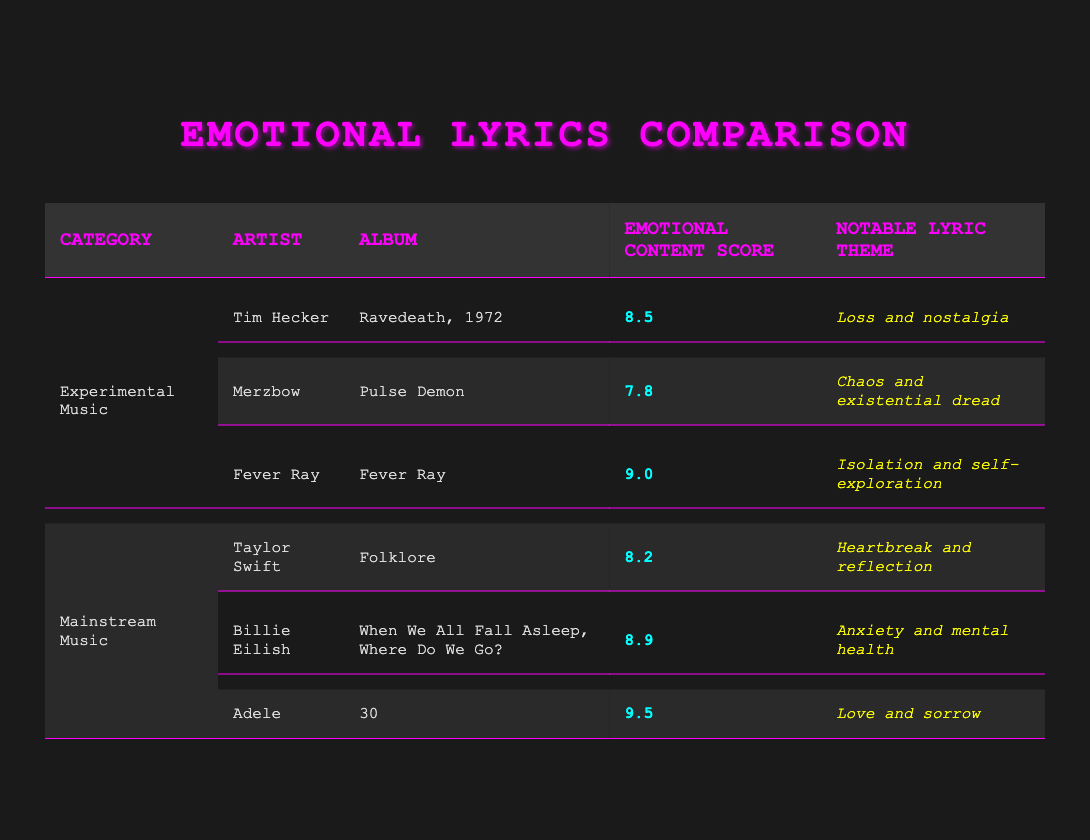What is the emotional content score of Fever Ray's album? The table shows that Fever Ray's album "Fever Ray" has an emotional content score of 9.0.
Answer: 9.0 Which artist has the highest emotional content score in mainstream music? From the table, Adele has the highest emotional content score of 9.5 in mainstream music, compared to Taylor Swift's 8.2 and Billie Eilish's 8.9.
Answer: Adele What is the notable lyric theme of Tim Hecker's album? According to the table, Tim Hecker's album "Ravedeath, 1972" has the notable lyric theme of "Loss and nostalgia."
Answer: Loss and nostalgia What is the average emotional content score of experimental music? The emotional content scores for experimental music are 8.5, 7.8, and 9.0. Summing these values gives 25.3 (8.5 + 7.8 + 9.0) and dividing by 3 (number of artists) results in an average of 8.43.
Answer: 8.43 Is there any artist in experimental music with an emotional content score higher than 9.0? The table lists Fever Ray with a score of 9.0, but no other experimental artist's score exceeds this; Tim Hecker and Merzbow score lower. Therefore, the answer is no.
Answer: No Which mainstream artist has a notable lyric theme related to anxiety? The table indicates that Billie Eilish has a notable lyric theme of "Anxiety and mental health."
Answer: Billie Eilish What is the sum of the emotional content scores for both Tim Hecker and Taylor Swift? Tim Hecker's score is 8.5 and Taylor Swift's score is 8.2. Adding these values gives a total of 16.7 (8.5 + 8.2).
Answer: 16.7 Is the emotional content score of Merzbow greater than 8.0? According to the table, Merzbow's emotional content score is 7.8, which is less than 8.0. Hence, the answer is no.
Answer: No What is the notable lyric theme of Adele's album "30"? The table specifies that the notable lyric theme of Adele's album "30" is "Love and sorrow."
Answer: Love and sorrow 